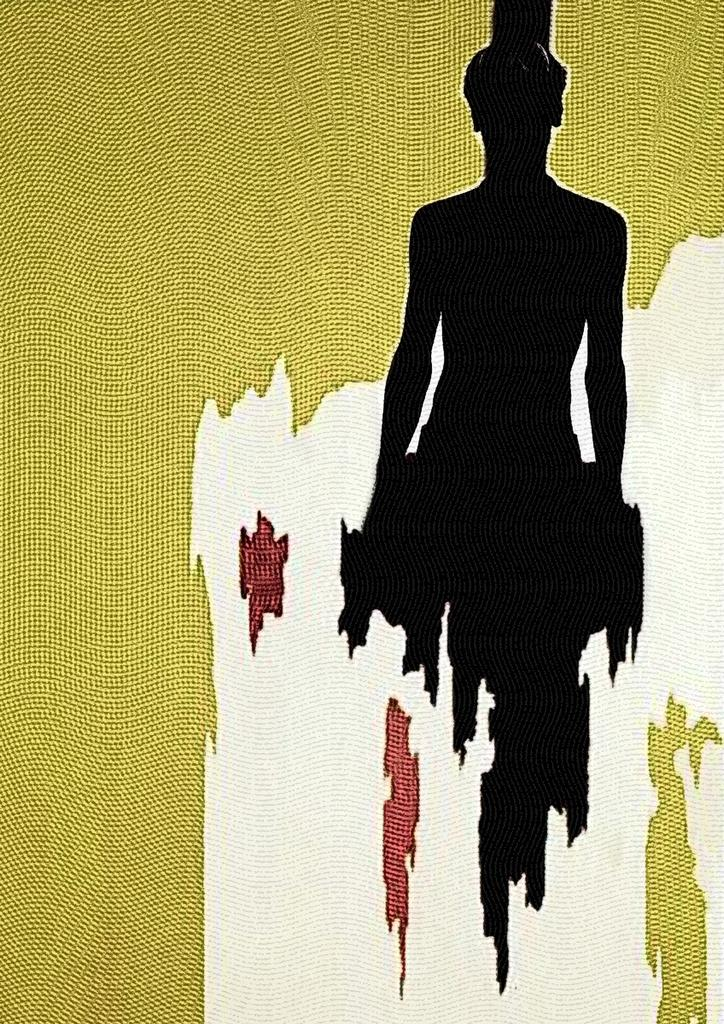What is present in the image? There is a poster in the image. What is depicted on the poster? The poster contains a woman's picture. What color is the woman's picture on the poster? The woman's picture is in black color. What arithmetic problem is the woman solving in the image? There is no arithmetic problem or indication of the woman solving any problem in the image. 